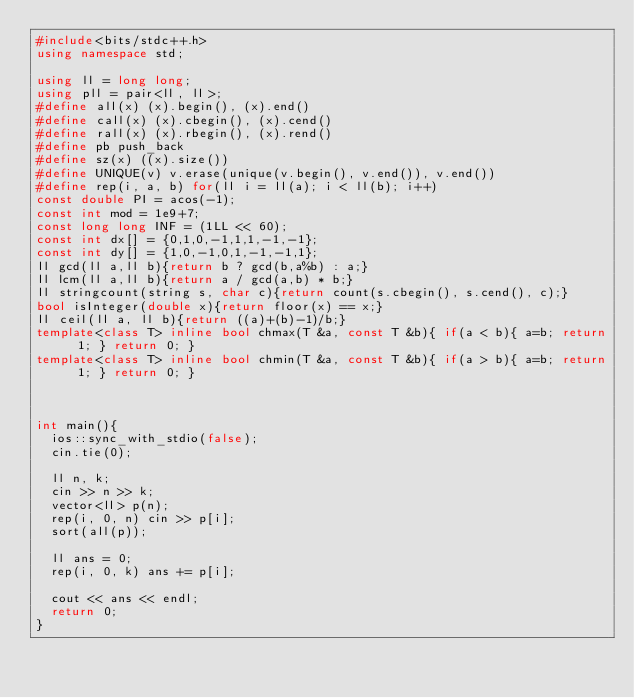<code> <loc_0><loc_0><loc_500><loc_500><_C++_>#include<bits/stdc++.h>
using namespace std;
 
using ll = long long;
using pll = pair<ll, ll>;
#define all(x) (x).begin(), (x).end()
#define call(x) (x).cbegin(), (x).cend()
#define rall(x) (x).rbegin(), (x).rend()
#define pb push_back
#define sz(x) ((x).size())
#define UNIQUE(v) v.erase(unique(v.begin(), v.end()), v.end())
#define rep(i, a, b) for(ll i = ll(a); i < ll(b); i++)
const double PI = acos(-1);
const int mod = 1e9+7;
const long long INF = (1LL << 60);
const int dx[] = {0,1,0,-1,1,1,-1,-1};
const int dy[] = {1,0,-1,0,1,-1,-1,1};
ll gcd(ll a,ll b){return b ? gcd(b,a%b) : a;}
ll lcm(ll a,ll b){return a / gcd(a,b) * b;}
ll stringcount(string s, char c){return count(s.cbegin(), s.cend(), c);}
bool isInteger(double x){return floor(x) == x;}
ll ceil(ll a, ll b){return ((a)+(b)-1)/b;}
template<class T> inline bool chmax(T &a, const T &b){ if(a < b){ a=b; return 1; } return 0; }
template<class T> inline bool chmin(T &a, const T &b){ if(a > b){ a=b; return 1; } return 0; }



int main(){
  ios::sync_with_stdio(false);
  cin.tie(0);

  ll n, k;
  cin >> n >> k;
  vector<ll> p(n);
  rep(i, 0, n) cin >> p[i];
  sort(all(p));

  ll ans = 0;
  rep(i, 0, k) ans += p[i];

  cout << ans << endl;
  return 0;
}</code> 